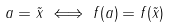<formula> <loc_0><loc_0><loc_500><loc_500>a = \tilde { x } \iff f ( a ) = f ( \tilde { x } )</formula> 